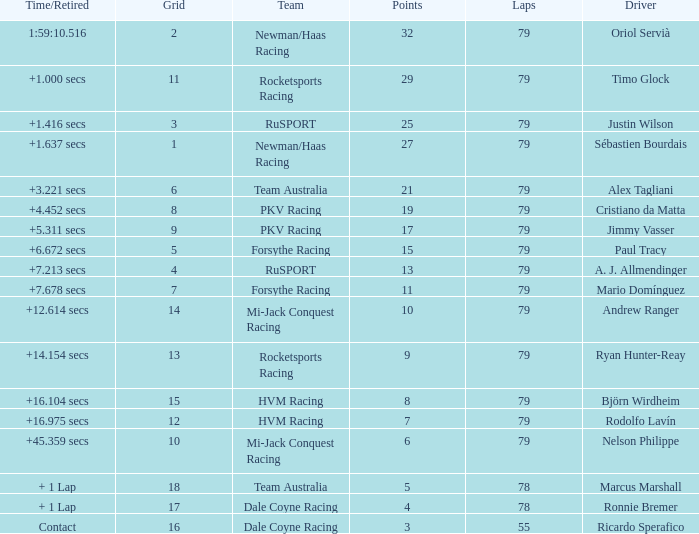Parse the table in full. {'header': ['Time/Retired', 'Grid', 'Team', 'Points', 'Laps', 'Driver'], 'rows': [['1:59:10.516', '2', 'Newman/Haas Racing', '32', '79', 'Oriol Servià'], ['+1.000 secs', '11', 'Rocketsports Racing', '29', '79', 'Timo Glock'], ['+1.416 secs', '3', 'RuSPORT', '25', '79', 'Justin Wilson'], ['+1.637 secs', '1', 'Newman/Haas Racing', '27', '79', 'Sébastien Bourdais'], ['+3.221 secs', '6', 'Team Australia', '21', '79', 'Alex Tagliani'], ['+4.452 secs', '8', 'PKV Racing', '19', '79', 'Cristiano da Matta'], ['+5.311 secs', '9', 'PKV Racing', '17', '79', 'Jimmy Vasser'], ['+6.672 secs', '5', 'Forsythe Racing', '15', '79', 'Paul Tracy'], ['+7.213 secs', '4', 'RuSPORT', '13', '79', 'A. J. Allmendinger'], ['+7.678 secs', '7', 'Forsythe Racing', '11', '79', 'Mario Domínguez'], ['+12.614 secs', '14', 'Mi-Jack Conquest Racing', '10', '79', 'Andrew Ranger'], ['+14.154 secs', '13', 'Rocketsports Racing', '9', '79', 'Ryan Hunter-Reay'], ['+16.104 secs', '15', 'HVM Racing', '8', '79', 'Björn Wirdheim'], ['+16.975 secs', '12', 'HVM Racing', '7', '79', 'Rodolfo Lavín'], ['+45.359 secs', '10', 'Mi-Jack Conquest Racing', '6', '79', 'Nelson Philippe'], ['+ 1 Lap', '18', 'Team Australia', '5', '78', 'Marcus Marshall'], ['+ 1 Lap', '17', 'Dale Coyne Racing', '4', '78', 'Ronnie Bremer'], ['Contact', '16', 'Dale Coyne Racing', '3', '55', 'Ricardo Sperafico']]} Which points has the driver Paul Tracy? 15.0. 